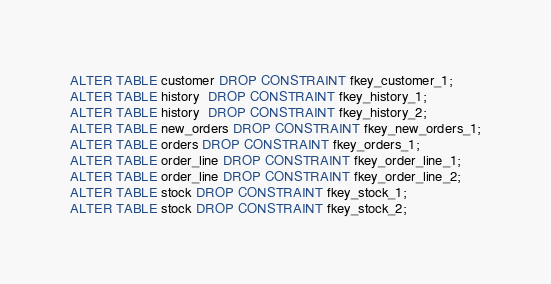<code> <loc_0><loc_0><loc_500><loc_500><_SQL_>ALTER TABLE customer DROP CONSTRAINT fkey_customer_1;
ALTER TABLE history  DROP CONSTRAINT fkey_history_1;
ALTER TABLE history  DROP CONSTRAINT fkey_history_2;
ALTER TABLE new_orders DROP CONSTRAINT fkey_new_orders_1;
ALTER TABLE orders DROP CONSTRAINT fkey_orders_1;
ALTER TABLE order_line DROP CONSTRAINT fkey_order_line_1;
ALTER TABLE order_line DROP CONSTRAINT fkey_order_line_2;
ALTER TABLE stock DROP CONSTRAINT fkey_stock_1;
ALTER TABLE stock DROP CONSTRAINT fkey_stock_2;

</code> 